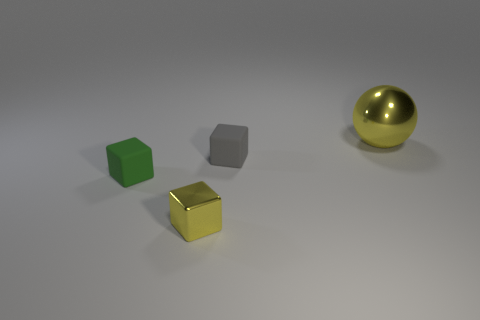Are there any other things that are the same size as the yellow shiny sphere?
Ensure brevity in your answer.  No. Is there a tiny metal object behind the yellow thing that is left of the big object?
Keep it short and to the point. No. There is a yellow object that is behind the tiny thing that is on the left side of the yellow metallic thing that is left of the yellow ball; what is its shape?
Give a very brief answer. Sphere. What color is the small object that is in front of the small gray matte thing and behind the small yellow block?
Offer a terse response. Green. The yellow metallic object left of the ball has what shape?
Offer a terse response. Cube. The thing that is the same material as the tiny green cube is what shape?
Ensure brevity in your answer.  Cube. What number of metal objects are small gray blocks or small purple cylinders?
Provide a succinct answer. 0. How many matte things are to the left of the tiny matte thing behind the small rubber block that is on the left side of the gray matte thing?
Provide a succinct answer. 1. Is the size of the thing to the left of the small yellow metal block the same as the shiny thing that is to the right of the tiny yellow block?
Make the answer very short. No. What material is the small green object that is the same shape as the tiny yellow metallic object?
Provide a short and direct response. Rubber. 